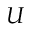<formula> <loc_0><loc_0><loc_500><loc_500>U</formula> 